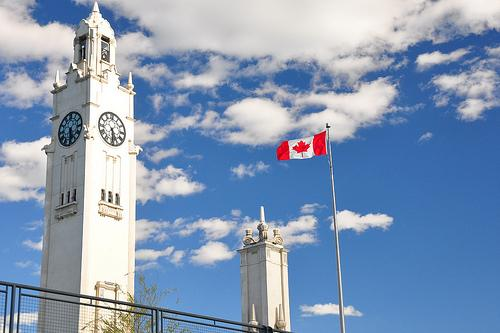What type of flag is visible in the image and where is it placed? A red and white Canadian flag is visible on a pole in the image. How many clocks are there on the tower and what color are their faces? There are two clocks on the tower, and their faces are black. What items can be found in the foreground of this image? A black metal fence, a tree, and a silver flag pole can be found in the foreground of the image. List the objects that are white in color within the image. White objects include the spire on a tower, a clock tower, a small tower, large tower, dome of the tower, clouds, and two white towers. Examine the fence in the image and comment on its appearance and purpose. The fence is a black metal protective fence in the forefront of the image, likely used for security or to mark a boundary. How would you characterize the overall atmosphere and weather conditions in this image? The image portrays a beautiful sunny day with a blue sky and white, wispy clouds. Identify the time shown on the clock and describe the design on the center of the clock face. The clock shows 5:30, and the center of the clock face has a blue design. Describe the architectural features of the tower in this image. The tower has a white clock, arched windows, finials, parapets, a closed door, and a white dome on top. Describe the sky and the presence of clouds in the image. The sky is blue with a lot of white clouds scattered throughout. Count the number of towers present in the image. There are two towers in the image. 